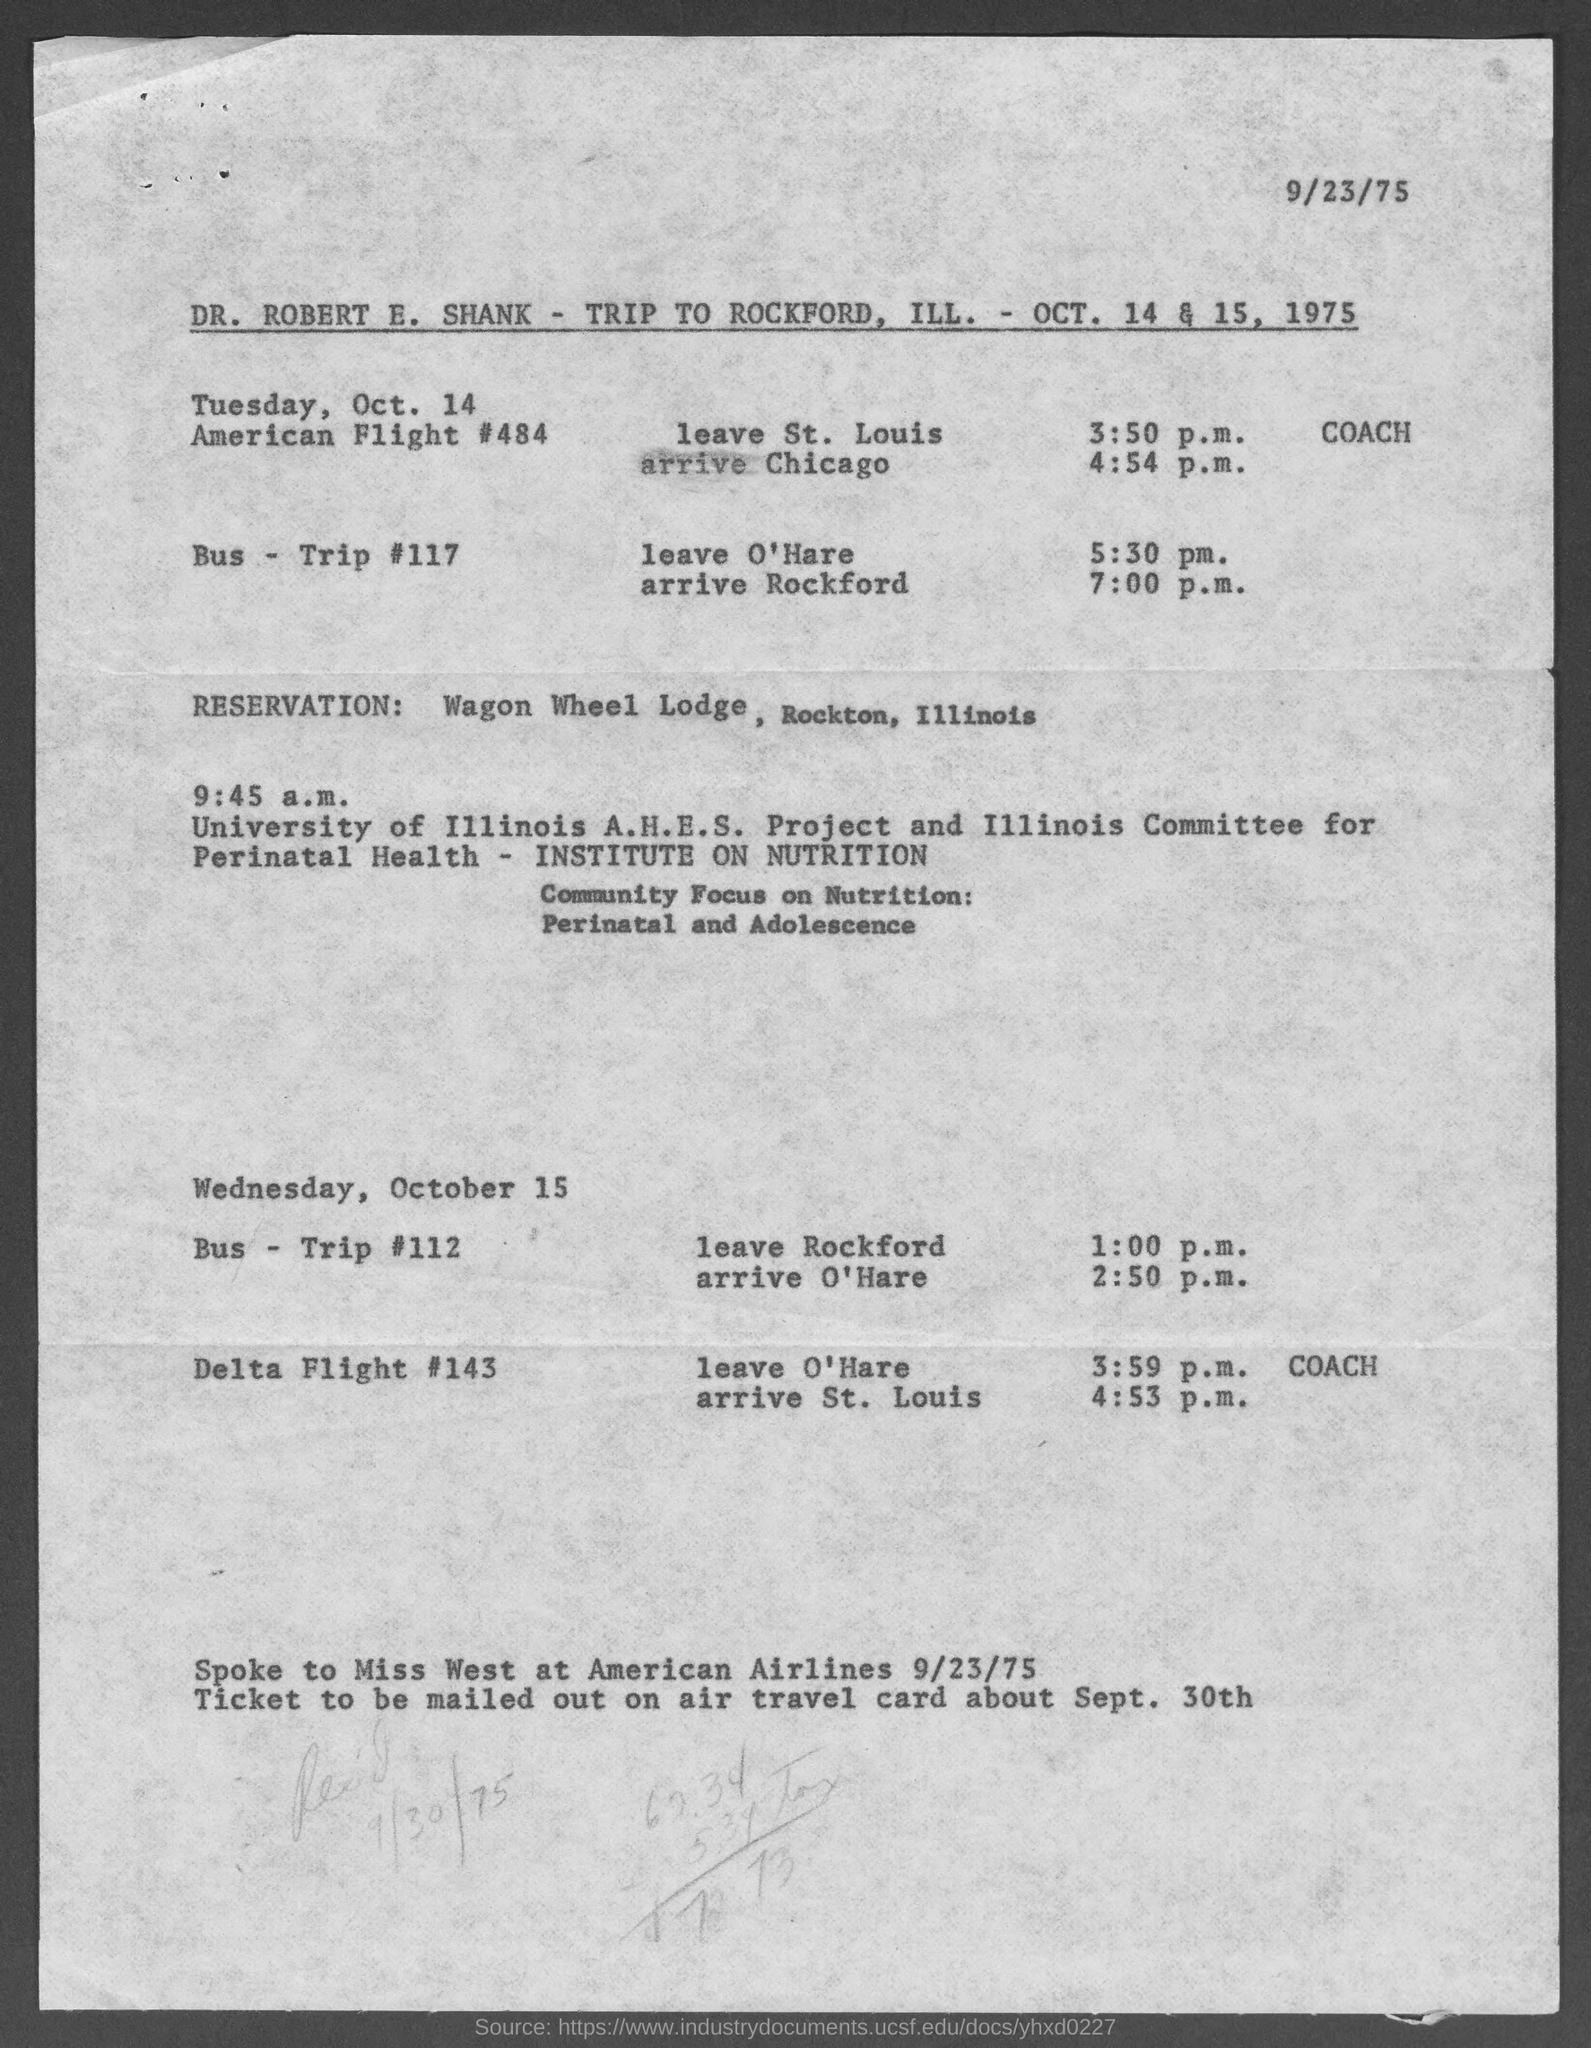List a handful of essential elements in this visual. The date displayed at the top-right of the page is 9/23/75. The reservation was made at Wagon Wheel Lodge, which is located in Rockton, Illinois. The trip details of Dr. Robert E. Shank are provided in the page. 